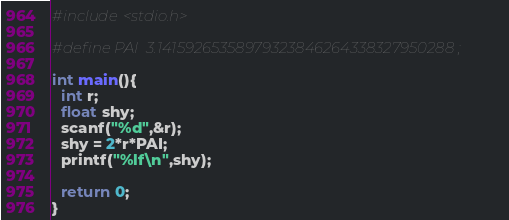<code> <loc_0><loc_0><loc_500><loc_500><_C_>#include<stdio.h>

#define PAI  3.14159265358979323846264338327950288 ;

int main(){
  int r;
  float shy;
  scanf("%d",&r);
  shy = 2*r*PAI;
  printf("%lf\n",shy);

  return 0;
}</code> 